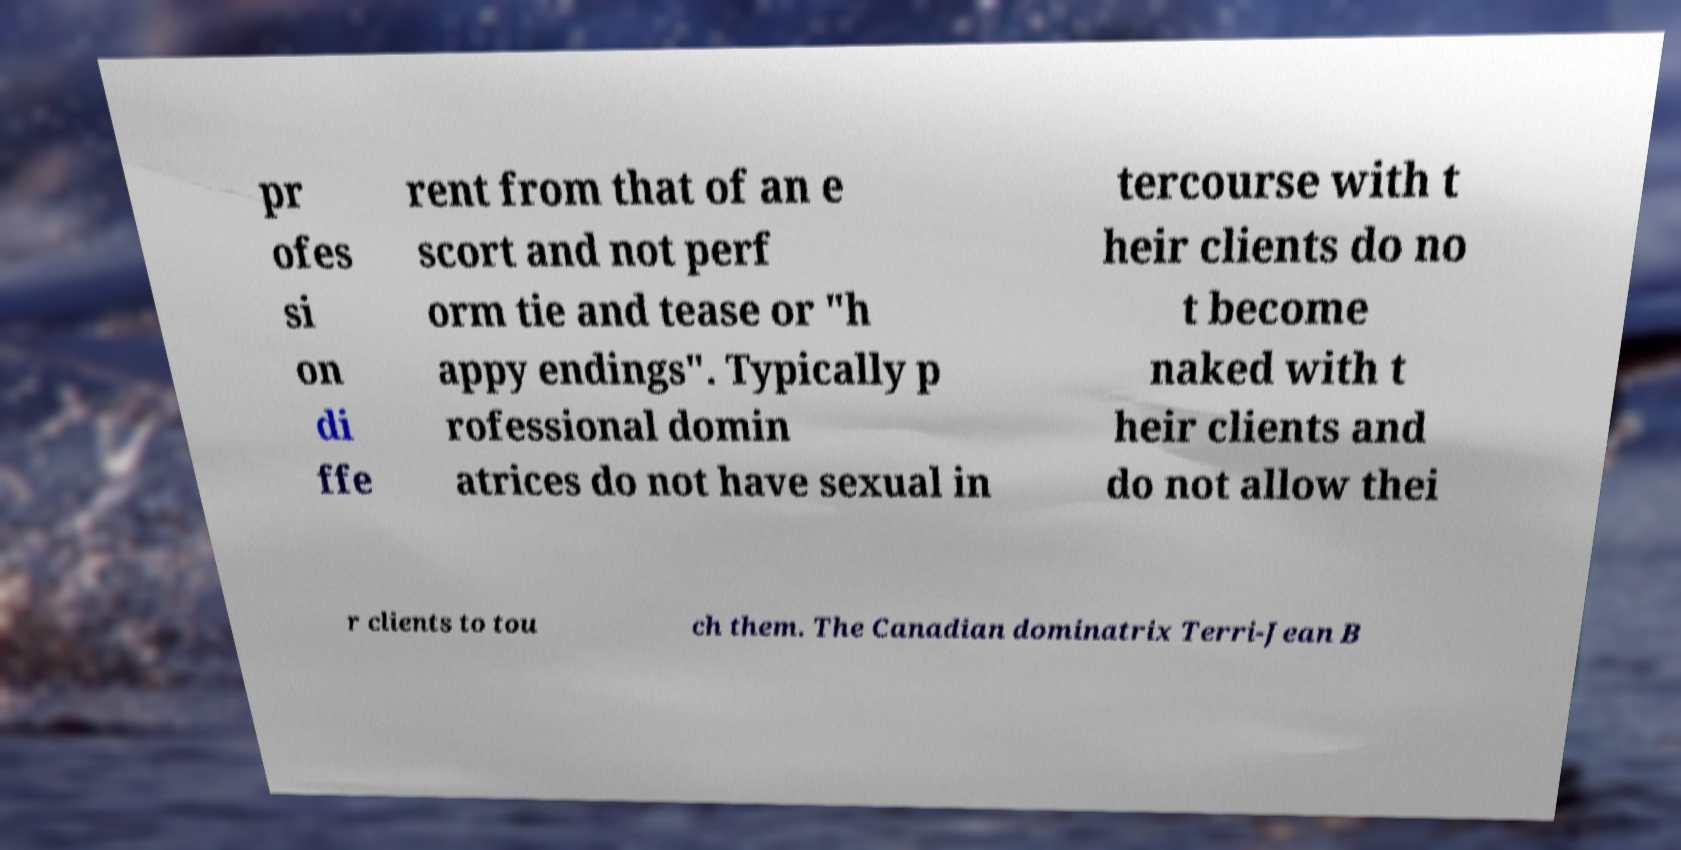Can you accurately transcribe the text from the provided image for me? pr ofes si on di ffe rent from that of an e scort and not perf orm tie and tease or "h appy endings". Typically p rofessional domin atrices do not have sexual in tercourse with t heir clients do no t become naked with t heir clients and do not allow thei r clients to tou ch them. The Canadian dominatrix Terri-Jean B 